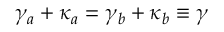<formula> <loc_0><loc_0><loc_500><loc_500>\gamma _ { a } + \kappa _ { a } = \gamma _ { b } + \kappa _ { b } \equiv \gamma</formula> 